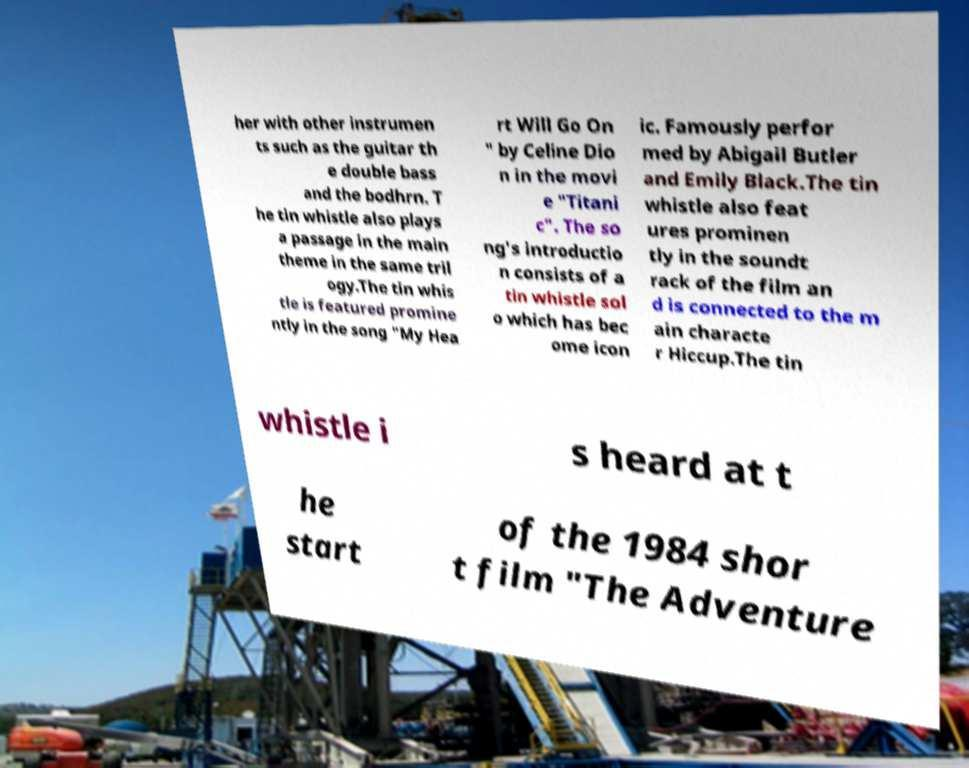Please read and relay the text visible in this image. What does it say? her with other instrumen ts such as the guitar th e double bass and the bodhrn. T he tin whistle also plays a passage in the main theme in the same tril ogy.The tin whis tle is featured promine ntly in the song "My Hea rt Will Go On " by Celine Dio n in the movi e "Titani c". The so ng's introductio n consists of a tin whistle sol o which has bec ome icon ic. Famously perfor med by Abigail Butler and Emily Black.The tin whistle also feat ures prominen tly in the soundt rack of the film an d is connected to the m ain characte r Hiccup.The tin whistle i s heard at t he start of the 1984 shor t film "The Adventure 